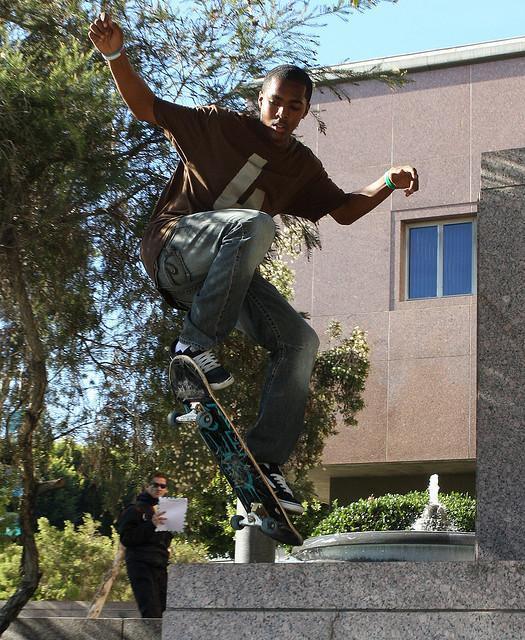How many people are in the photo?
Give a very brief answer. 2. 